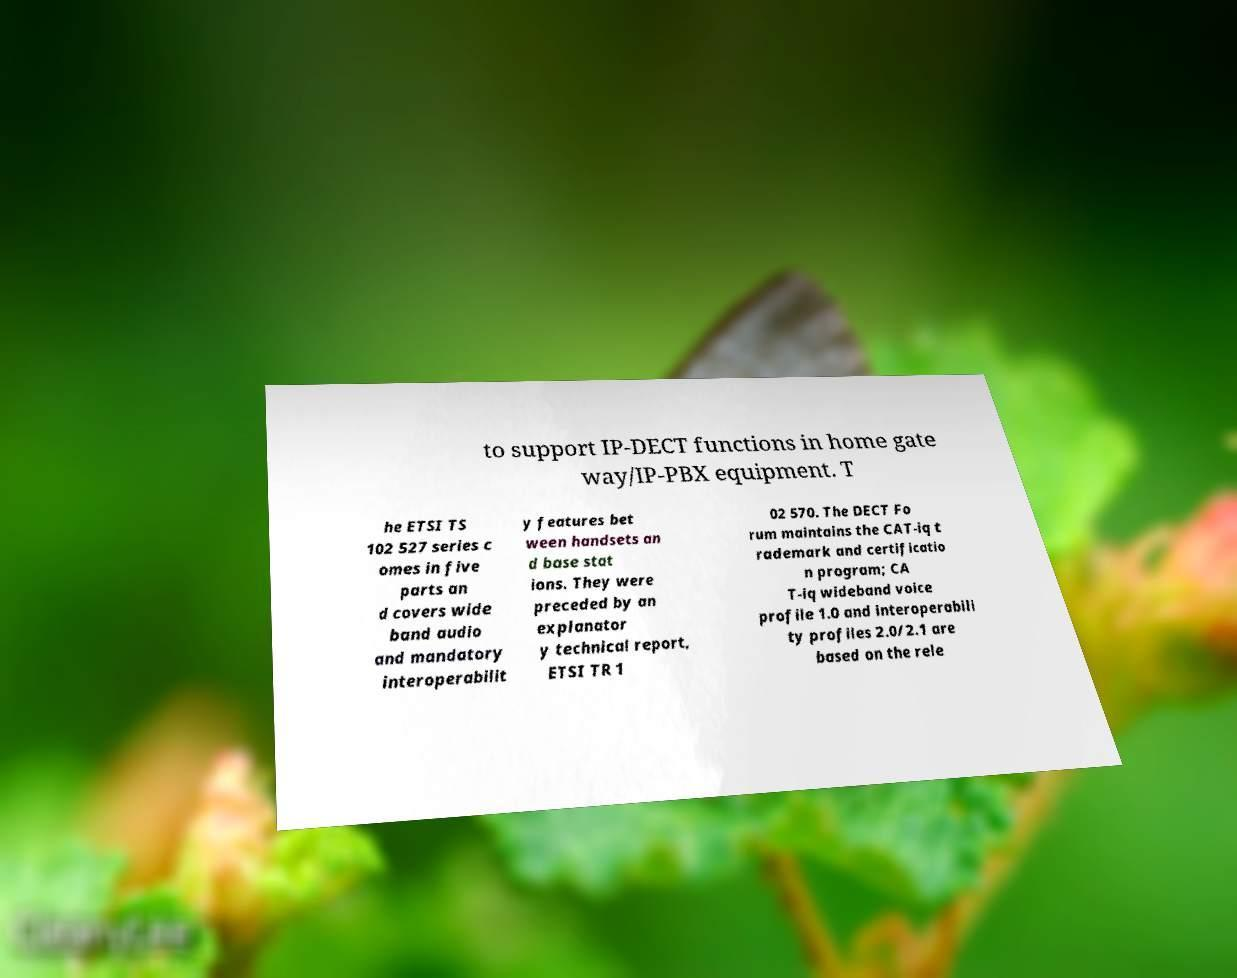What messages or text are displayed in this image? I need them in a readable, typed format. to support IP-DECT functions in home gate way/IP-PBX equipment. T he ETSI TS 102 527 series c omes in five parts an d covers wide band audio and mandatory interoperabilit y features bet ween handsets an d base stat ions. They were preceded by an explanator y technical report, ETSI TR 1 02 570. The DECT Fo rum maintains the CAT-iq t rademark and certificatio n program; CA T-iq wideband voice profile 1.0 and interoperabili ty profiles 2.0/2.1 are based on the rele 